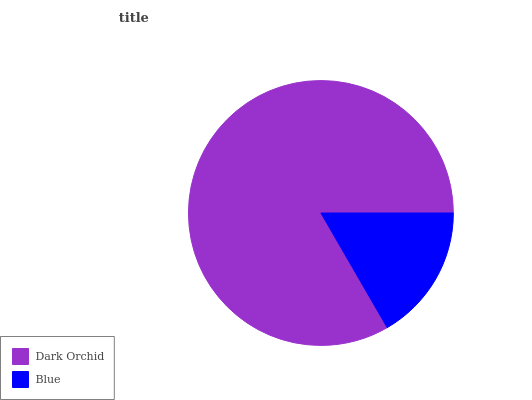Is Blue the minimum?
Answer yes or no. Yes. Is Dark Orchid the maximum?
Answer yes or no. Yes. Is Blue the maximum?
Answer yes or no. No. Is Dark Orchid greater than Blue?
Answer yes or no. Yes. Is Blue less than Dark Orchid?
Answer yes or no. Yes. Is Blue greater than Dark Orchid?
Answer yes or no. No. Is Dark Orchid less than Blue?
Answer yes or no. No. Is Dark Orchid the high median?
Answer yes or no. Yes. Is Blue the low median?
Answer yes or no. Yes. Is Blue the high median?
Answer yes or no. No. Is Dark Orchid the low median?
Answer yes or no. No. 